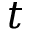Convert formula to latex. <formula><loc_0><loc_0><loc_500><loc_500>t</formula> 